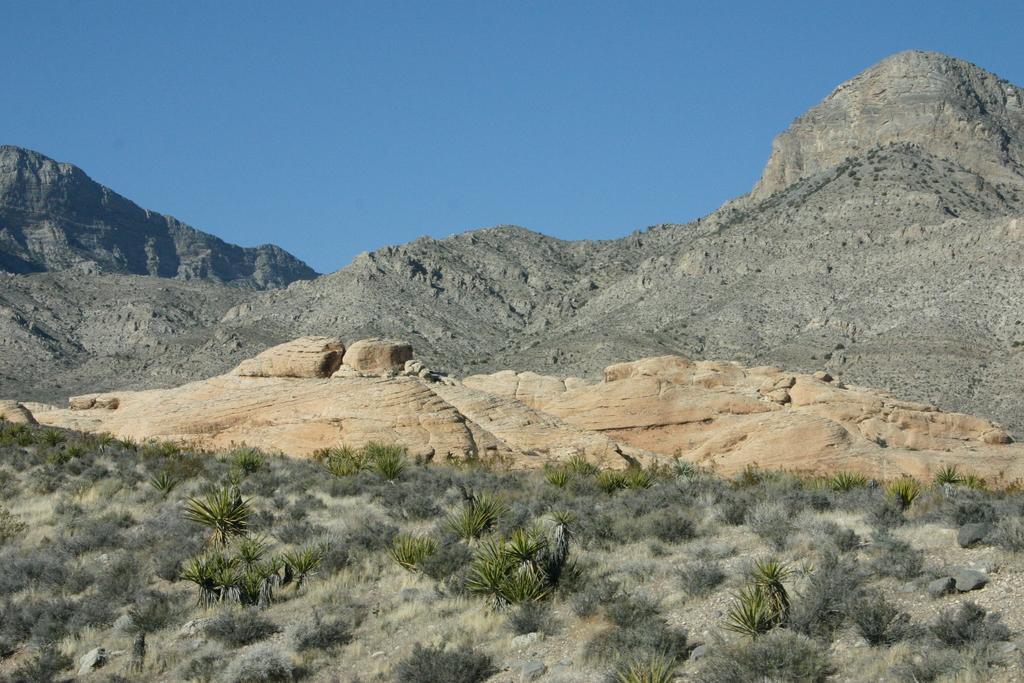What type of vegetation is present at the bottom of the image? There are plants and grass at the bottom of the image. What is the ground made of at the bottom of the image? The ground is made of grass at the bottom of the image. What can be seen in the background of the image? There are rocks, mountains, and the sky visible in the background of the image. What type of scarf is draped over the mountains in the image? There is no scarf present in the image; it features plants, grass, rocks, mountains, and the sky. What type of company is responsible for the steel structures in the image? There are no steel structures present in the image. 